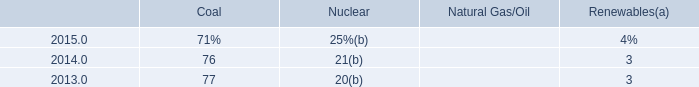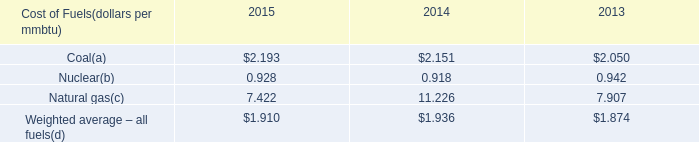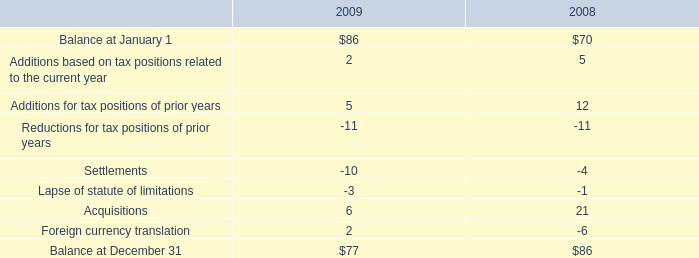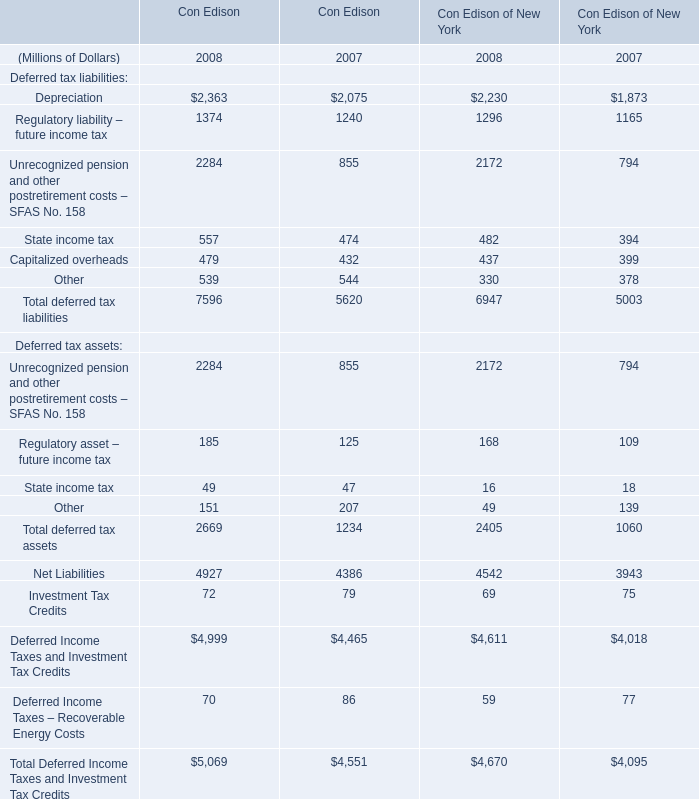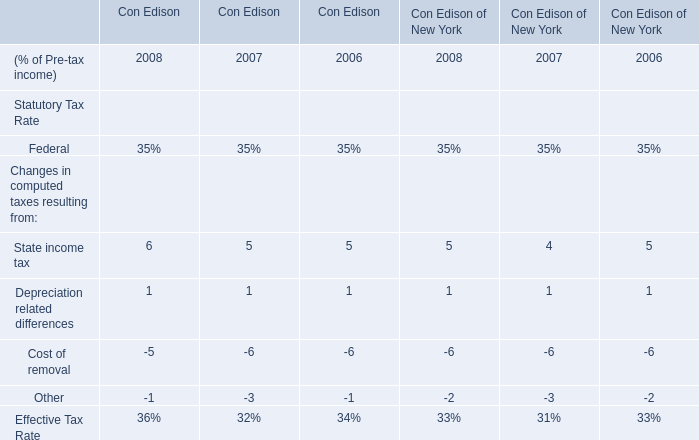considering the years 2008 and 2009 , what is the increase observed in the liability for interest? 
Computations: ((18 / 14) - 1)
Answer: 0.28571. 